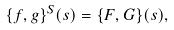Convert formula to latex. <formula><loc_0><loc_0><loc_500><loc_500>\{ f , g \} ^ { S } ( s ) = \{ F , G \} ( s ) ,</formula> 